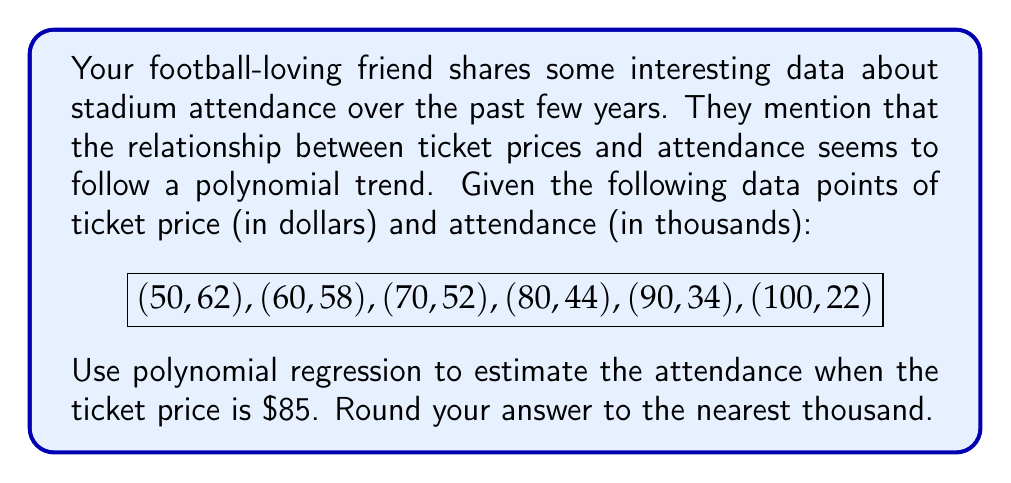Provide a solution to this math problem. To solve this problem, we'll use quadratic polynomial regression, as it's often sufficient for modeling such relationships. Here's the step-by-step process:

1) We assume the relationship follows the form: $y = ax^2 + bx + c$, where $y$ is attendance and $x$ is ticket price.

2) To find $a$, $b$, and $c$, we need to solve the following system of equations:

   $$\sum y = an\sum x^2 + bn\sum x + cn$$
   $$\sum xy = a\sum x^3 + b\sum x^2 + c\sum x$$
   $$\sum x^2y = a\sum x^4 + b\sum x^3 + c\sum x^2$$

3) Calculate the sums:
   $\sum x = 450$, $\sum y = 272$, $\sum x^2 = 36500$, $\sum xy = 19760$
   $\sum x^3 = 3125000$, $\sum x^4 = 276250000$, $\sum x^2y = 1657000$

4) Substitute these into the system of equations:

   $$272 = 36500a + 450b + 6c$$
   $$19760 = 3125000a + 36500b + 450c$$
   $$1657000 = 276250000a + 3125000b + 36500c$$

5) Solve this system (you can use a calculator or computer for this step). The result is:

   $$a \approx -0.0101, b \approx 0.8909, c \approx 79.0909$$

6) Our regression equation is therefore:

   $$y \approx -0.0101x^2 + 0.8909x + 79.0909$$

7) To estimate attendance when the ticket price is $85, substitute $x = 85$:

   $$y \approx -0.0101(85^2) + 0.8909(85) + 79.0909$$
   $$y \approx -72.9625 + 75.7265 + 79.0909$$
   $$y \approx 81.8549$$

8) Rounding to the nearest thousand:

   $$y \approx 82$$
Answer: 82,000 